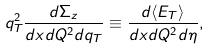<formula> <loc_0><loc_0><loc_500><loc_500>q _ { T } ^ { 2 } \frac { d \Sigma _ { z } } { d x d Q ^ { 2 } d q _ { T } } \equiv \frac { d \langle E _ { T } \rangle } { d x d Q ^ { 2 } d \eta } ,</formula> 